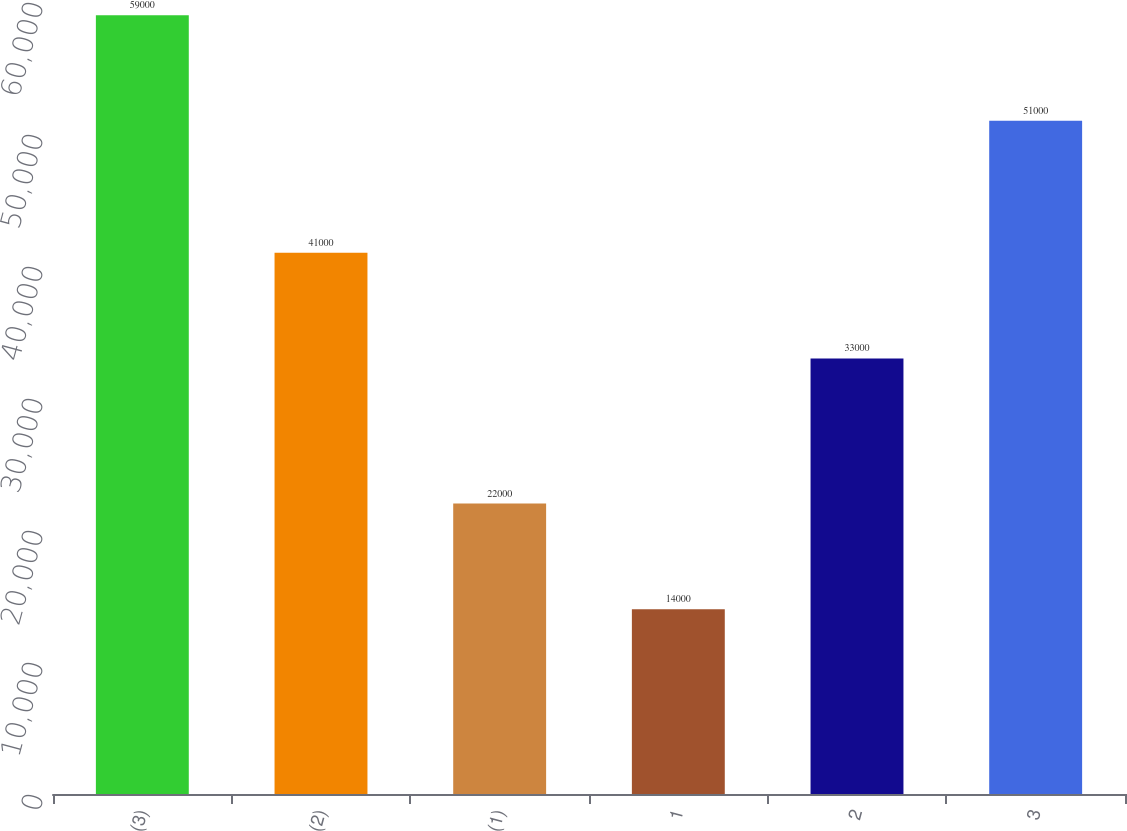Convert chart. <chart><loc_0><loc_0><loc_500><loc_500><bar_chart><fcel>(3)<fcel>(2)<fcel>(1)<fcel>1<fcel>2<fcel>3<nl><fcel>59000<fcel>41000<fcel>22000<fcel>14000<fcel>33000<fcel>51000<nl></chart> 